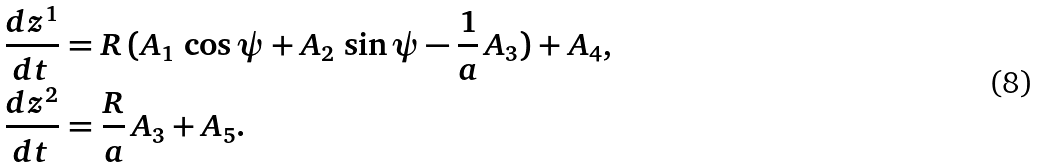<formula> <loc_0><loc_0><loc_500><loc_500>& \frac { d z ^ { 1 } } { d t } = R \, ( A _ { 1 } \, \cos \psi + A _ { 2 } \, \sin \psi - \frac { 1 } { a } \, A _ { 3 } ) + A _ { 4 } , \\ & \frac { d z ^ { 2 } } { d t } = \frac { R } { a } \, A _ { 3 } + A _ { 5 } .</formula> 